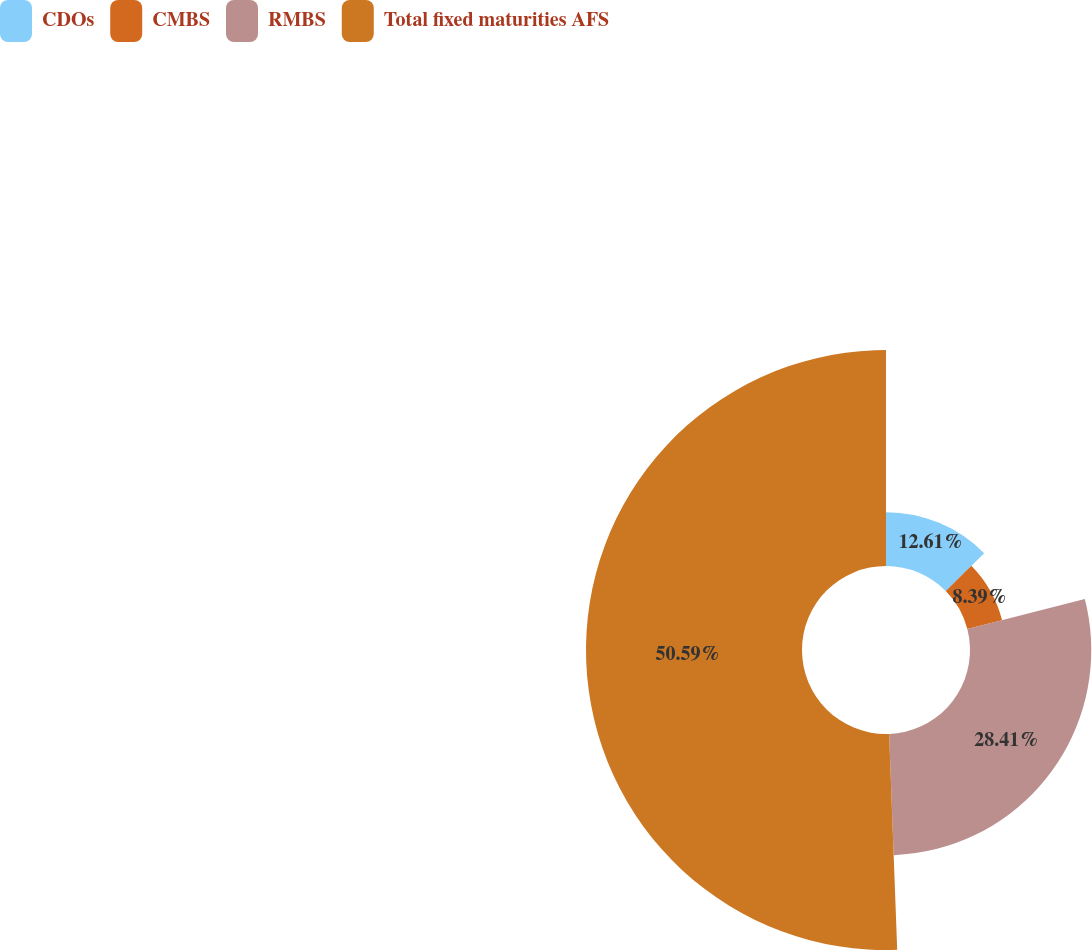<chart> <loc_0><loc_0><loc_500><loc_500><pie_chart><fcel>CDOs<fcel>CMBS<fcel>RMBS<fcel>Total fixed maturities AFS<nl><fcel>12.61%<fcel>8.39%<fcel>28.41%<fcel>50.6%<nl></chart> 